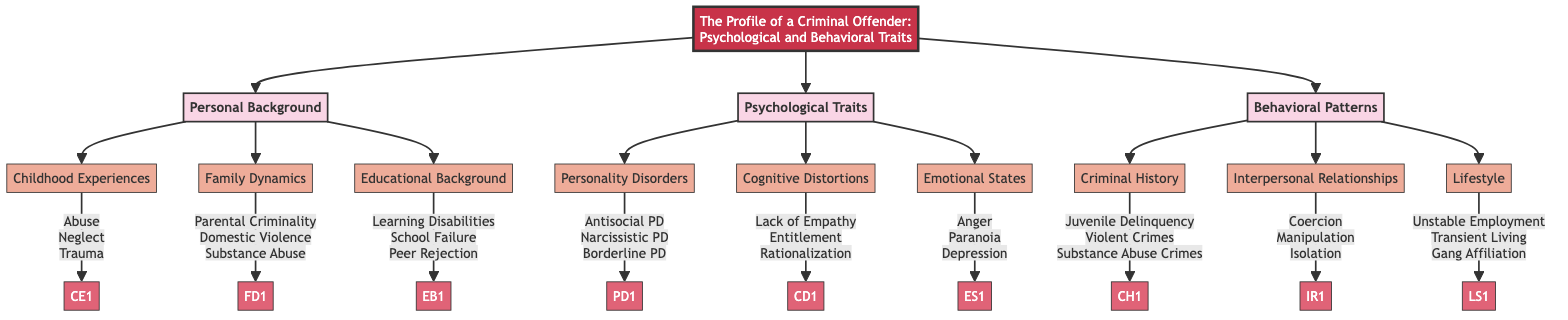What is the main title of the diagram? The title of the diagram is prominently displayed at the top and reads "The Profile of a Criminal Offender: Psychological and Behavioral Traits."
Answer: The Profile of a Criminal Offender: Psychological and Behavioral Traits How many main blocks are present in the diagram? There are three main blocks labeled Personal Background, Psychological Traits, and Behavioral Patterns. Counting these blocks gives a total of three main blocks.
Answer: 3 What are the details associated with “Childhood Experiences”? By looking at the sub-block under Personal Background labeled Childhood Experiences, we can see that the details associated with it are Abuse, Neglect, and Trauma.
Answer: Abuse, Neglect, Trauma Which sub-block is connected to Emotional States? The sub-block connected to Emotional States is part of the Psychological Traits block. It is labeled as Emotional States.
Answer: Emotional States What kind of disorders are included under Personality Disorders? The details under Personality Disorders include Antisocial Personality Disorder, Narcissistic Personality Disorder, and Borderline Personality Disorder, indicating the types of disorders categorized here.
Answer: Antisocial Personality Disorder, Narcissistic Personality Disorder, Borderline Personality Disorder How are the elements of the "Behavioral Patterns" block categorized? The elements under the Behavioral Patterns block include Criminal History, Interpersonal Relationships, and Lifestyle, showing a categorization of different behavioral aspects of offenders.
Answer: Criminal History, Interpersonal Relationships, Lifestyle What would be the first element listed under Psychological Traits? The diagram shows that the first element listed under Psychological Traits is Personality Disorders, as it appears first in the flow below Psychological Traits.
Answer: Personality Disorders Which block includes "Juvenile Delinquency" as a detail? Juvenile Delinquency appears as a detail within the Criminal History sub-block, which is part of the Behavioral Patterns block.
Answer: Criminal History Which psychological trait is associated with "Lack of Empathy"? Lack of Empathy is mentioned as a detail under the Cognitive Distortions element, which is a sub-block of Psychological Traits.
Answer: Cognitive Distortions 